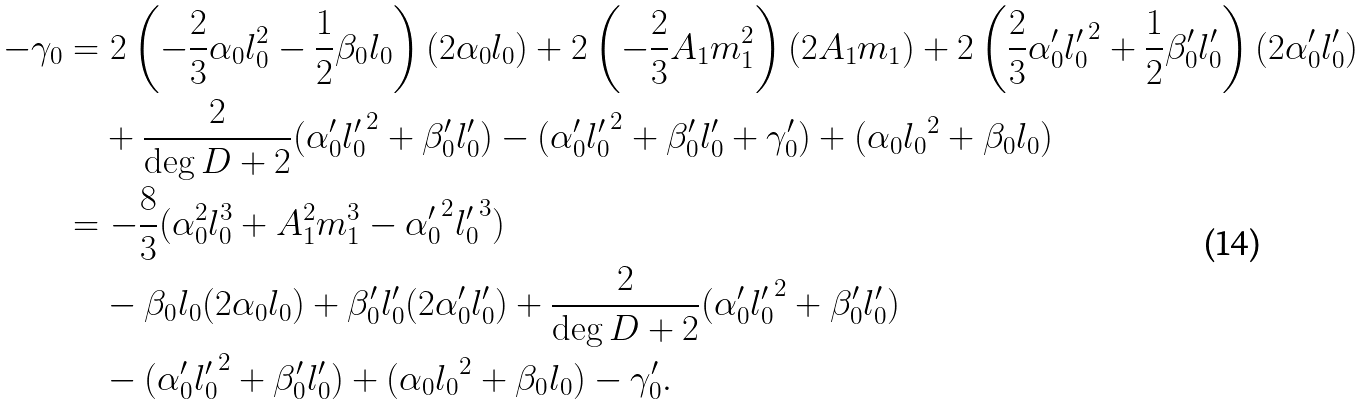Convert formula to latex. <formula><loc_0><loc_0><loc_500><loc_500>- \gamma _ { 0 } & = 2 \left ( - \frac { 2 } { 3 } \alpha _ { 0 } l _ { 0 } ^ { 2 } - \frac { 1 } { 2 } \beta _ { 0 } l _ { 0 } \right ) ( 2 \alpha _ { 0 } l _ { 0 } ) + 2 \left ( - \frac { 2 } { 3 } A _ { 1 } m _ { 1 } ^ { 2 } \right ) ( 2 A _ { 1 } m _ { 1 } ) + 2 \left ( \frac { 2 } { 3 } \alpha _ { 0 } ^ { \prime } { l _ { 0 } ^ { \prime } } ^ { 2 } + \frac { 1 } { 2 } \beta _ { 0 } ^ { \prime } l _ { 0 } ^ { \prime } \right ) ( 2 \alpha _ { 0 } ^ { \prime } l _ { 0 } ^ { \prime } ) \\ & \quad + \frac { 2 } { \deg D + 2 } ( \alpha _ { 0 } ^ { \prime } { l _ { 0 } ^ { \prime } } ^ { 2 } + \beta _ { 0 } ^ { \prime } l _ { 0 } ^ { \prime } ) - ( \alpha _ { 0 } ^ { \prime } { l _ { 0 } ^ { \prime } } ^ { 2 } + \beta _ { 0 } ^ { \prime } l _ { 0 } ^ { \prime } + \gamma _ { 0 } ^ { \prime } ) + ( \alpha _ { 0 } { l _ { 0 } } ^ { 2 } + \beta _ { 0 } l _ { 0 } ) \\ & = - \frac { 8 } { 3 } ( \alpha _ { 0 } ^ { 2 } l _ { 0 } ^ { 3 } + A _ { 1 } ^ { 2 } m _ { 1 } ^ { 3 } - { \alpha _ { 0 } ^ { \prime } } ^ { 2 } { l _ { 0 } ^ { \prime } } ^ { 3 } ) \\ & \quad - \beta _ { 0 } l _ { 0 } ( 2 \alpha _ { 0 } l _ { 0 } ) + \beta _ { 0 } ^ { \prime } l _ { 0 } ^ { \prime } ( 2 \alpha _ { 0 } ^ { \prime } l _ { 0 } ^ { \prime } ) + \frac { 2 } { \deg D + 2 } ( \alpha _ { 0 } ^ { \prime } { l _ { 0 } ^ { \prime } } ^ { 2 } + \beta _ { 0 } ^ { \prime } l _ { 0 } ^ { \prime } ) \\ & \quad - ( \alpha _ { 0 } ^ { \prime } { l _ { 0 } ^ { \prime } } ^ { 2 } + \beta _ { 0 } ^ { \prime } l _ { 0 } ^ { \prime } ) + ( \alpha _ { 0 } { l _ { 0 } } ^ { 2 } + \beta _ { 0 } l _ { 0 } ) - \gamma _ { 0 } ^ { \prime } .</formula> 